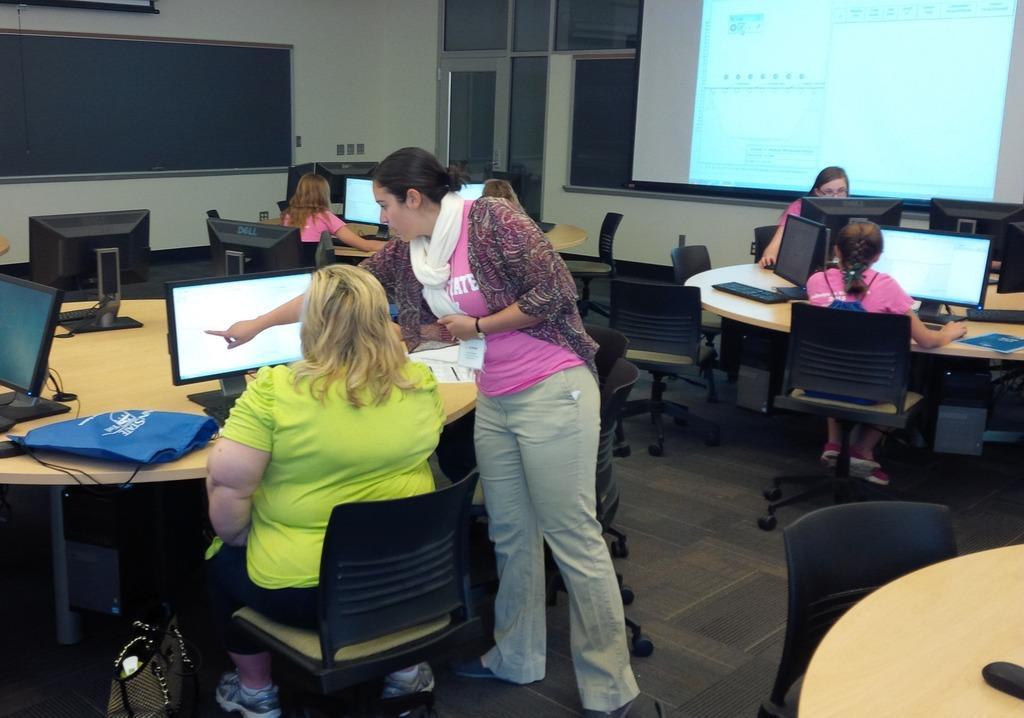In one or two sentences, can you explain what this image depicts? In this picture we can see group of people few are seated on the chair, and one person is standing and she is showing the monitor to the another woman, in front of her we can find a bag on the table. 